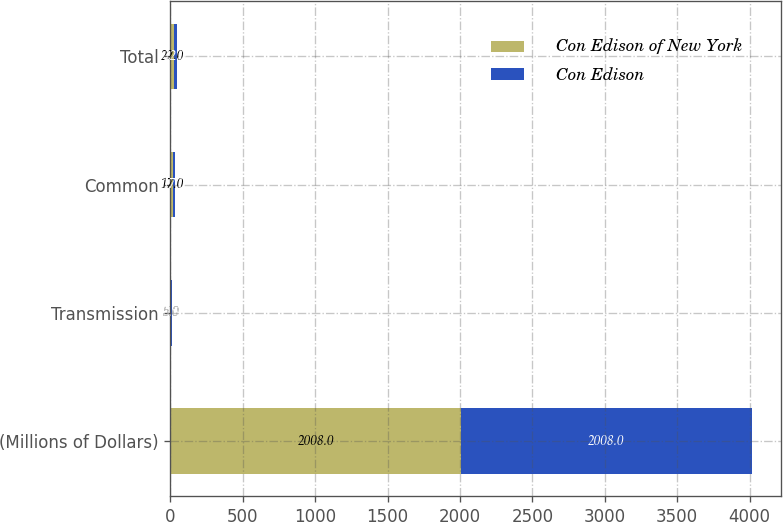Convert chart. <chart><loc_0><loc_0><loc_500><loc_500><stacked_bar_chart><ecel><fcel>(Millions of Dollars)<fcel>Transmission<fcel>Common<fcel>Total<nl><fcel>Con Edison of New York<fcel>2008<fcel>5<fcel>17<fcel>22<nl><fcel>Con Edison<fcel>2008<fcel>5<fcel>17<fcel>22<nl></chart> 